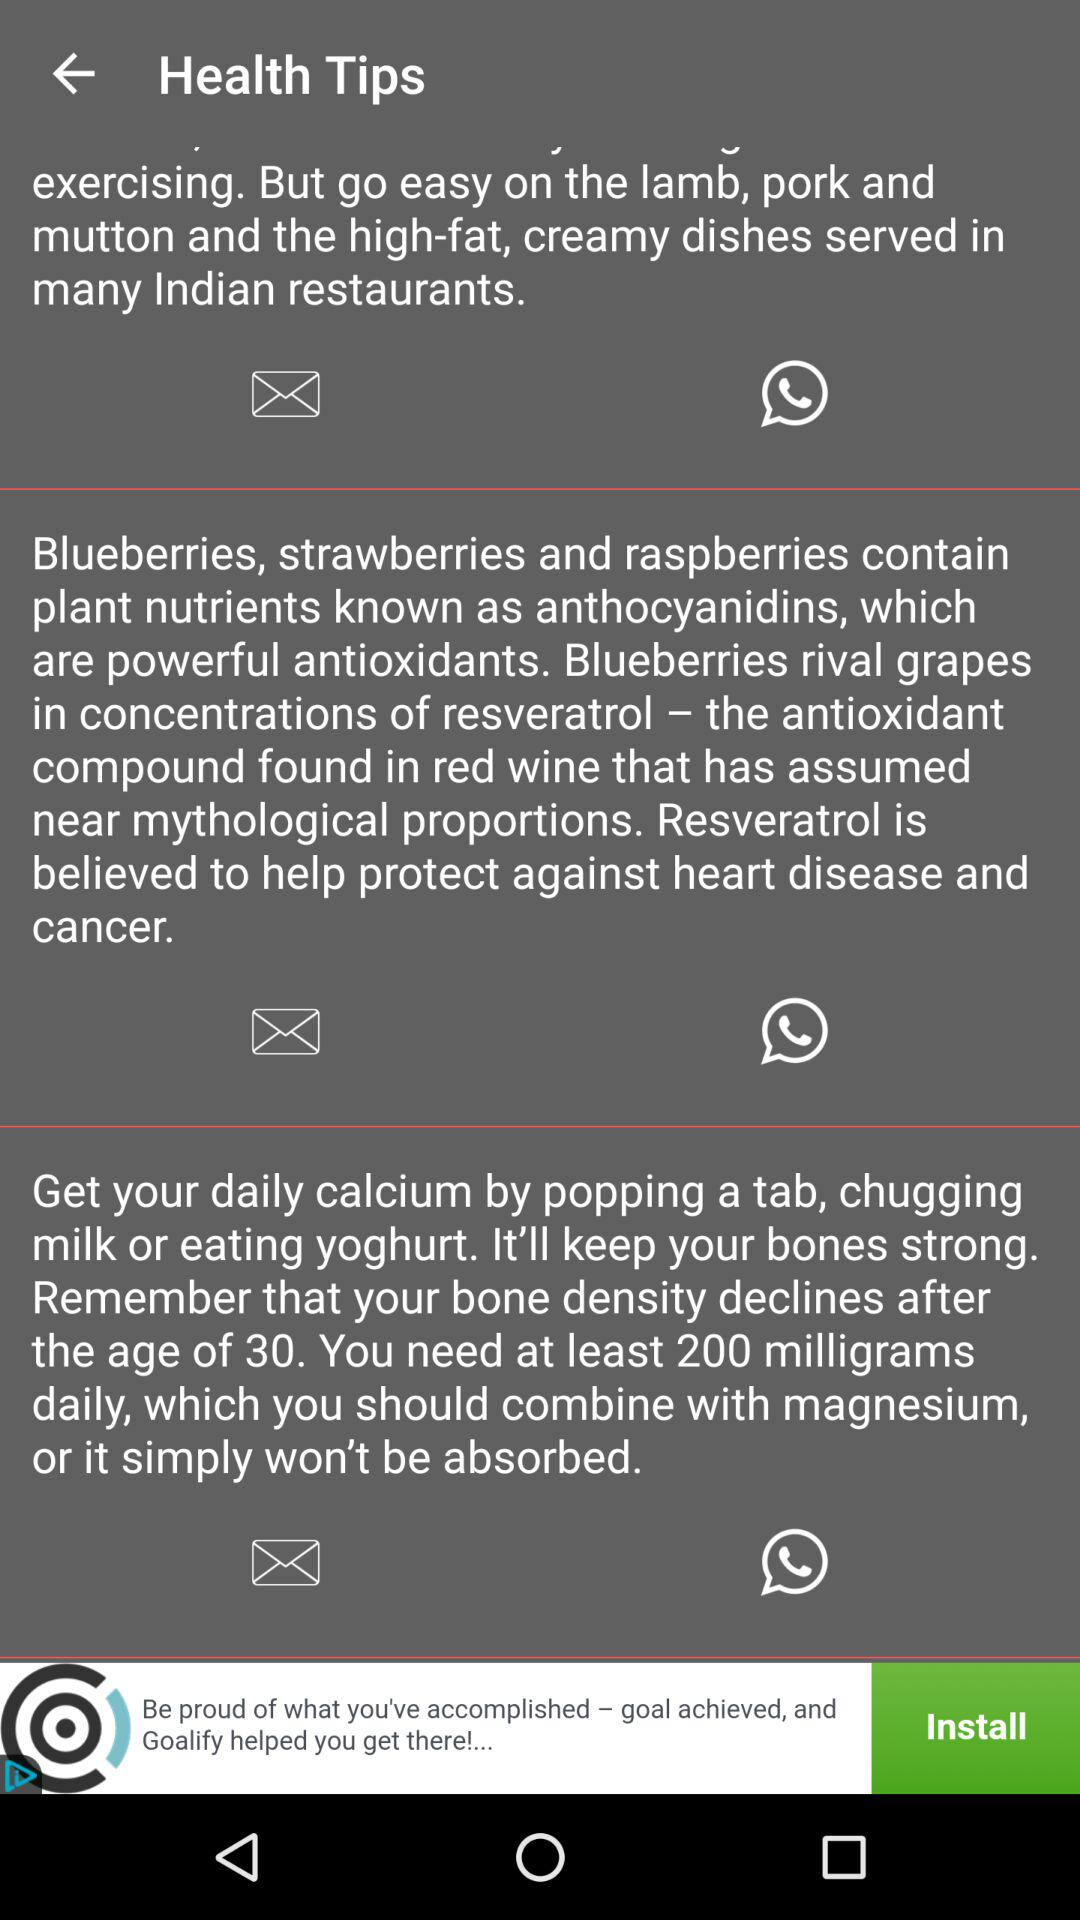Which supplement protects us from heart diseases and cancer? The supplement that protects us from heart diseases and cancer is "Resveratrol". 